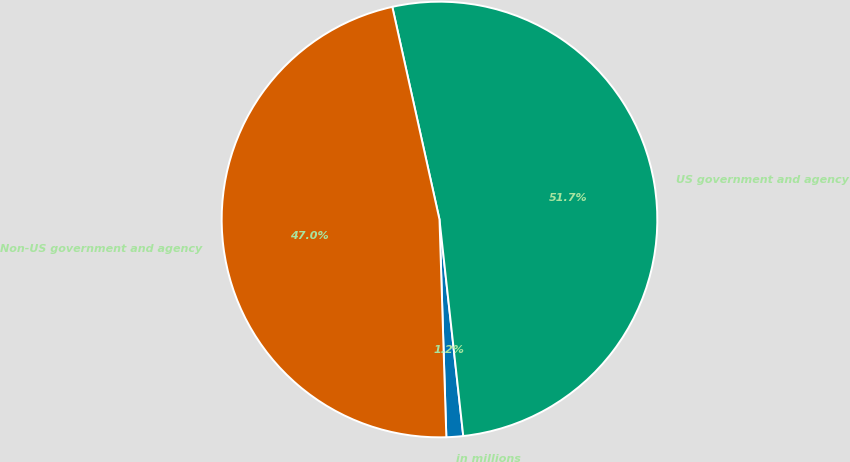Convert chart. <chart><loc_0><loc_0><loc_500><loc_500><pie_chart><fcel>in millions<fcel>US government and agency<fcel>Non-US government and agency<nl><fcel>1.24%<fcel>51.74%<fcel>47.03%<nl></chart> 